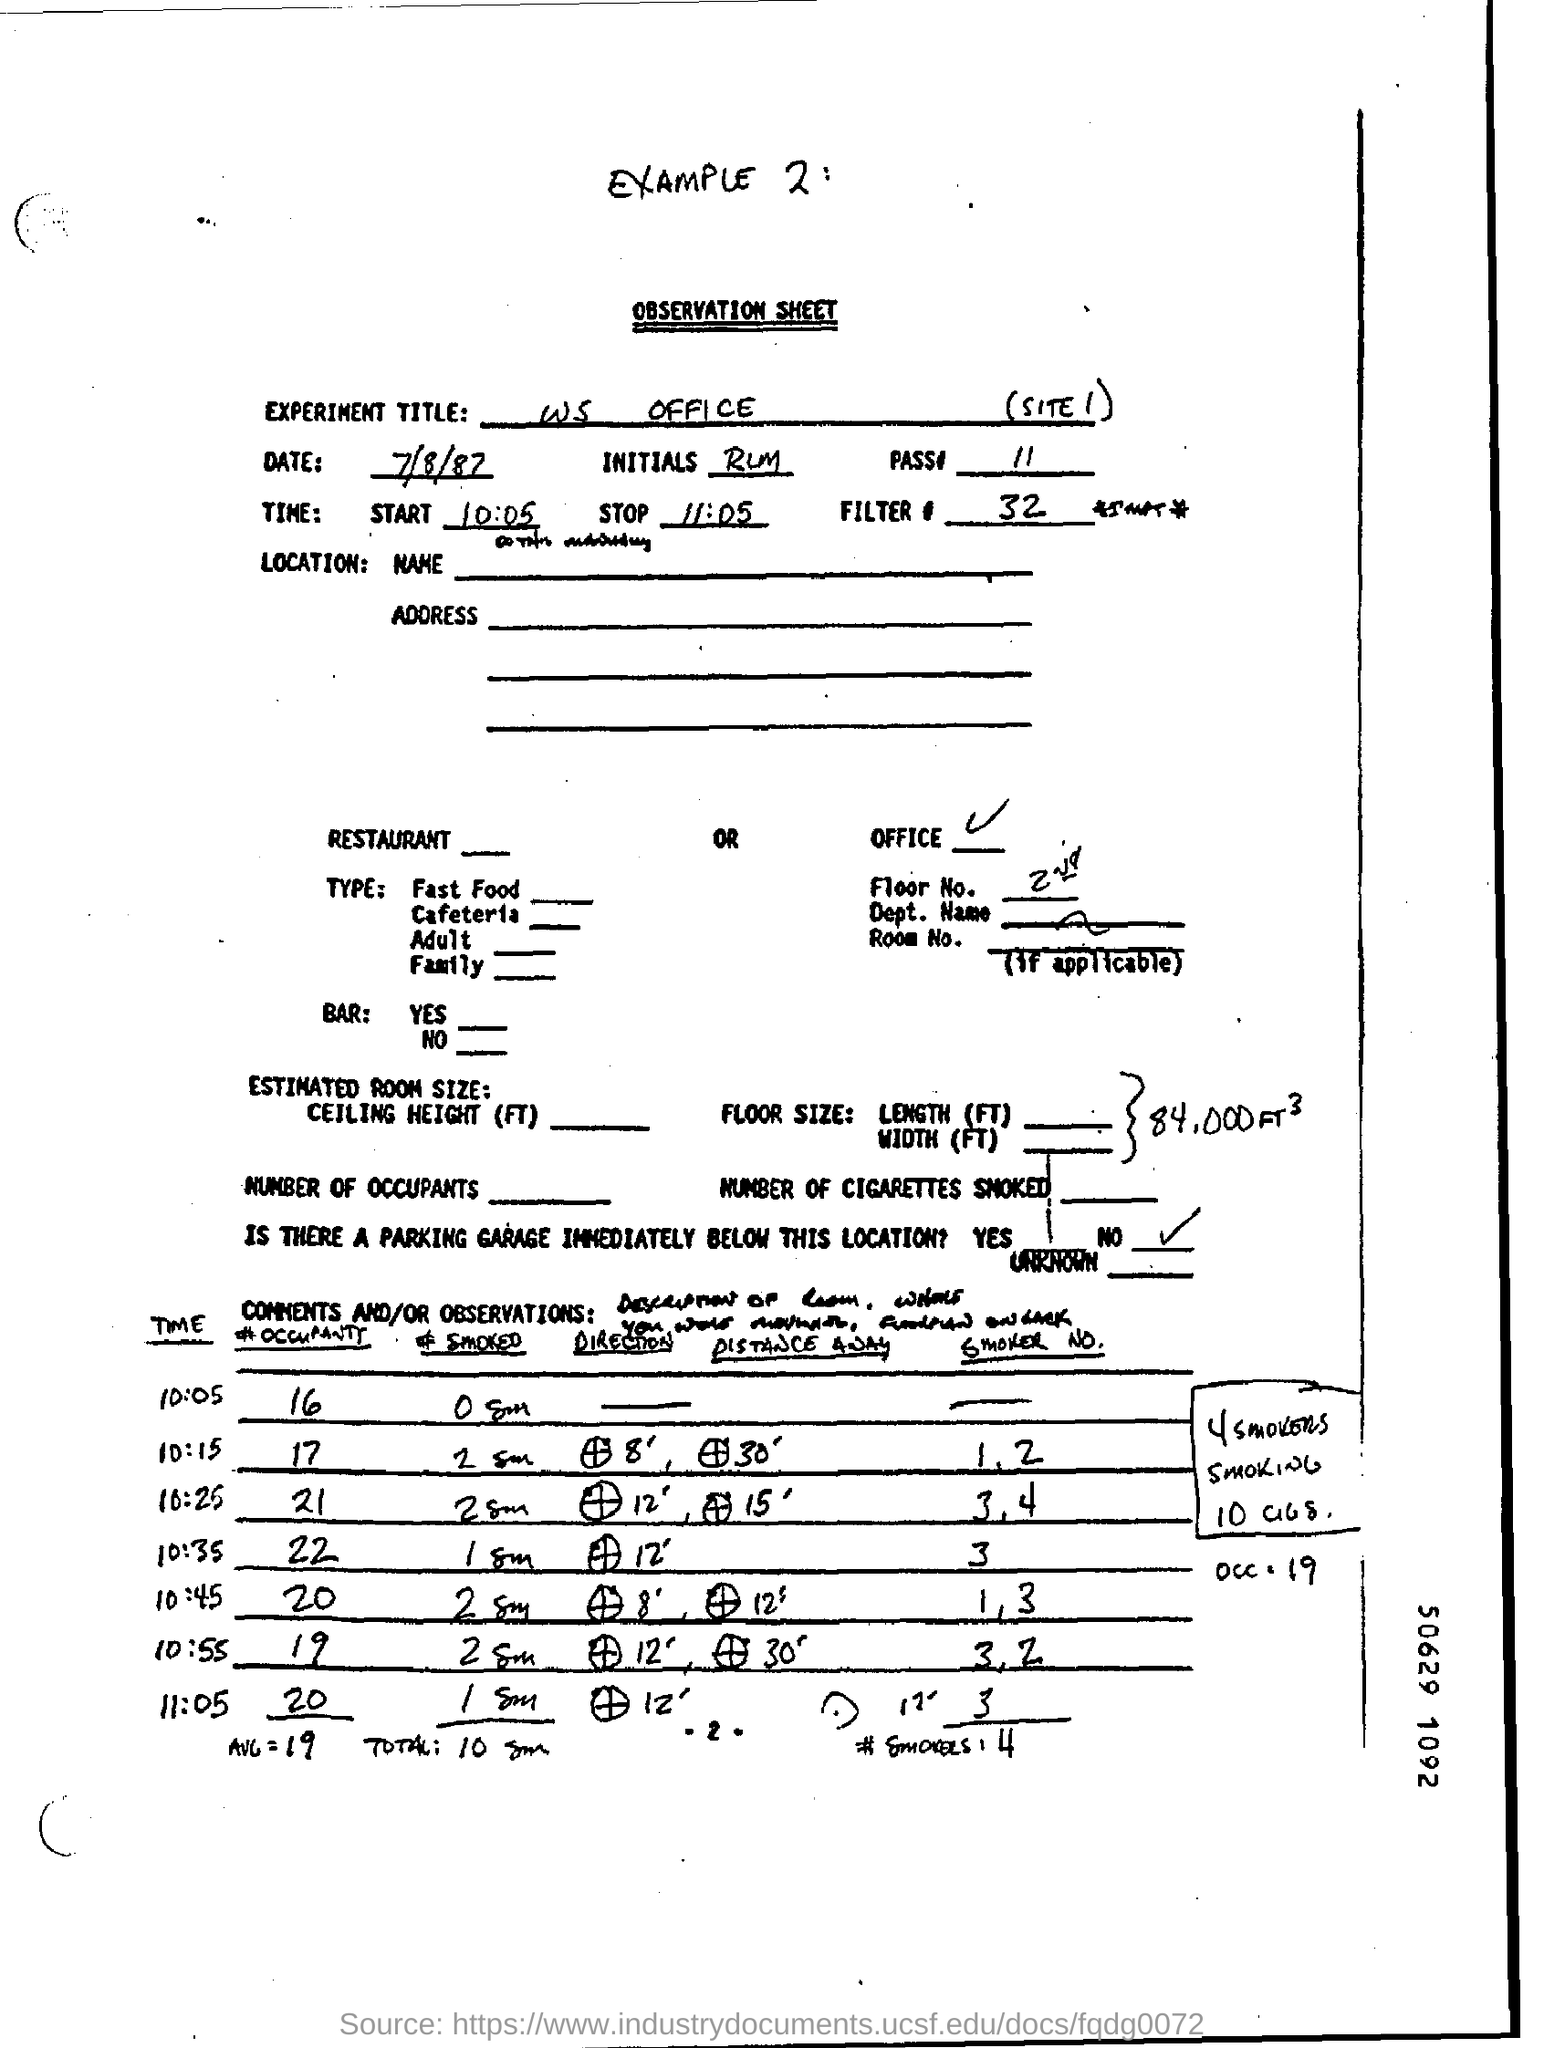Point out several critical features in this image. The stopping time is 11:05. At the starting time of 10:05,... 